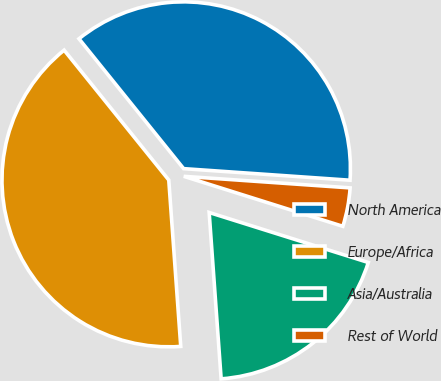<chart> <loc_0><loc_0><loc_500><loc_500><pie_chart><fcel>North America<fcel>Europe/Africa<fcel>Asia/Australia<fcel>Rest of World<nl><fcel>36.9%<fcel>40.35%<fcel>19.01%<fcel>3.74%<nl></chart> 